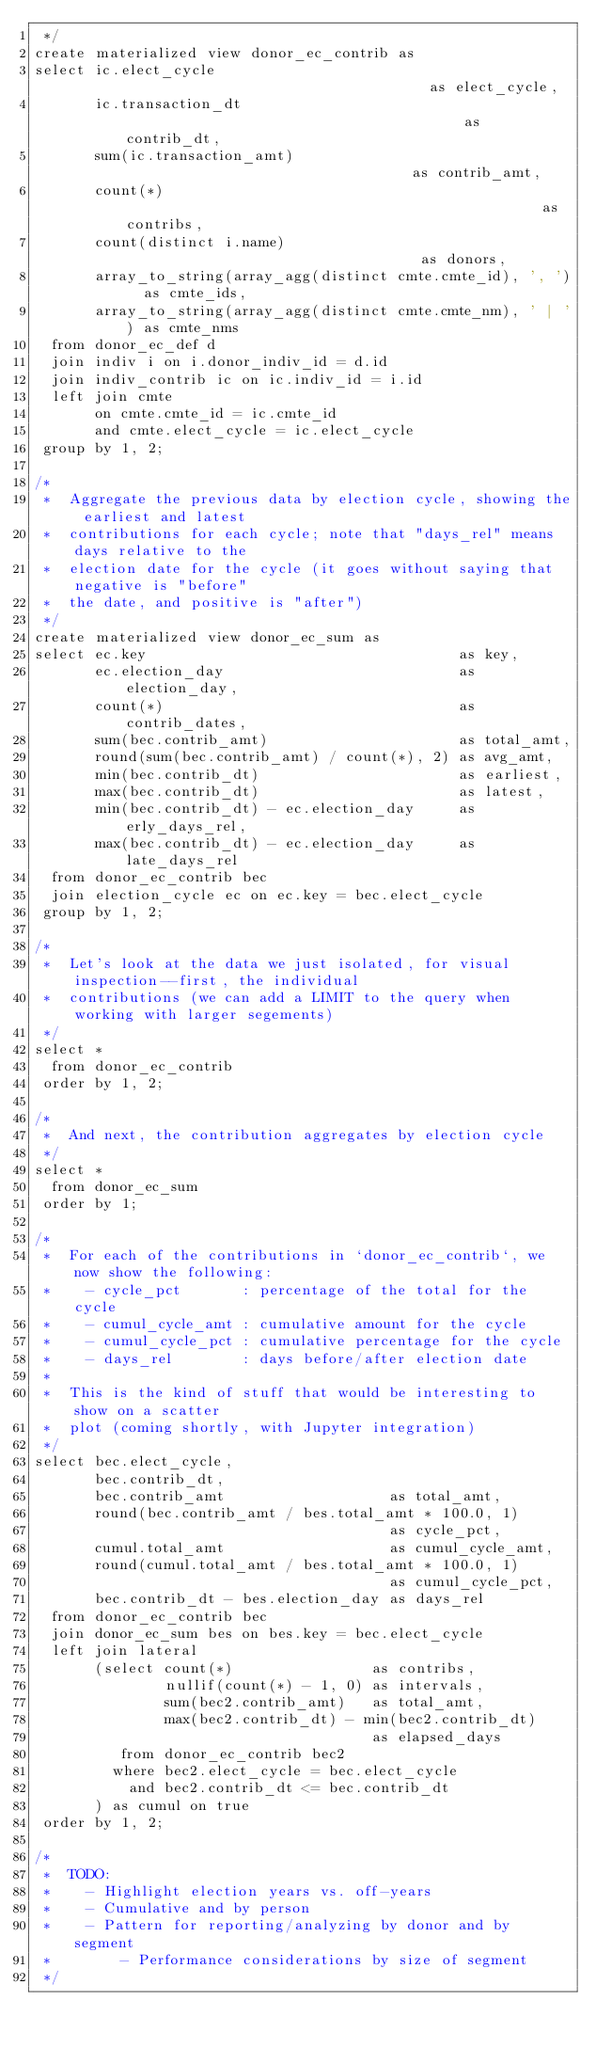Convert code to text. <code><loc_0><loc_0><loc_500><loc_500><_SQL_> */
create materialized view donor_ec_contrib as
select ic.elect_cycle                                           as elect_cycle,
       ic.transaction_dt                                        as contrib_dt,
       sum(ic.transaction_amt)                                  as contrib_amt,
       count(*)                                                 as contribs,
       count(distinct i.name)                                   as donors,
       array_to_string(array_agg(distinct cmte.cmte_id), ', ')  as cmte_ids,
       array_to_string(array_agg(distinct cmte.cmte_nm), ' | ') as cmte_nms
  from donor_ec_def d
  join indiv i on i.donor_indiv_id = d.id
  join indiv_contrib ic on ic.indiv_id = i.id
  left join cmte
       on cmte.cmte_id = ic.cmte_id
       and cmte.elect_cycle = ic.elect_cycle
 group by 1, 2;

/*
 *  Aggregate the previous data by election cycle, showing the earliest and latest
 *  contributions for each cycle; note that "days_rel" means days relative to the
 *  election date for the cycle (it goes without saying that negative is "before"
 *  the date, and positive is "after")
 */
create materialized view donor_ec_sum as
select ec.key                                    as key,
       ec.election_day                           as election_day,
       count(*)                                  as contrib_dates,
       sum(bec.contrib_amt)                      as total_amt,
       round(sum(bec.contrib_amt) / count(*), 2) as avg_amt,
       min(bec.contrib_dt)                       as earliest,
       max(bec.contrib_dt)                       as latest,
       min(bec.contrib_dt) - ec.election_day     as erly_days_rel,
       max(bec.contrib_dt) - ec.election_day     as late_days_rel
  from donor_ec_contrib bec
  join election_cycle ec on ec.key = bec.elect_cycle
 group by 1, 2;

/*
 *  Let's look at the data we just isolated, for visual inspection--first, the individual
 *  contributions (we can add a LIMIT to the query when working with larger segements)
 */
select *
  from donor_ec_contrib
 order by 1, 2;

/*
 *  And next, the contribution aggregates by election cycle
 */
select *
  from donor_ec_sum
 order by 1;

/*
 *  For each of the contributions in `donor_ec_contrib`, we now show the following:
 *    - cycle_pct       : percentage of the total for the cycle
 *    - cumul_cycle_amt : cumulative amount for the cycle
 *    - cumul_cycle_pct : cumulative percentage for the cycle
 *    - days_rel        : days before/after election date
 *
 *  This is the kind of stuff that would be interesting to show on a scatter
 *  plot (coming shortly, with Jupyter integration)
 */
select bec.elect_cycle,
       bec.contrib_dt,
       bec.contrib_amt                   as total_amt,
       round(bec.contrib_amt / bes.total_amt * 100.0, 1)
                                         as cycle_pct,
       cumul.total_amt                   as cumul_cycle_amt,
       round(cumul.total_amt / bes.total_amt * 100.0, 1)
                                         as cumul_cycle_pct,
       bec.contrib_dt - bes.election_day as days_rel
  from donor_ec_contrib bec
  join donor_ec_sum bes on bes.key = bec.elect_cycle
  left join lateral
       (select count(*)                as contribs,
               nullif(count(*) - 1, 0) as intervals,
               sum(bec2.contrib_amt)   as total_amt,
               max(bec2.contrib_dt) - min(bec2.contrib_dt)
                                       as elapsed_days
          from donor_ec_contrib bec2
         where bec2.elect_cycle = bec.elect_cycle
           and bec2.contrib_dt <= bec.contrib_dt
       ) as cumul on true
 order by 1, 2;

/*
 *  TODO:
 *    - Highlight election years vs. off-years
 *    - Cumulative and by person
 *    - Pattern for reporting/analyzing by donor and by segment
 *        - Performance considerations by size of segment
 */
</code> 